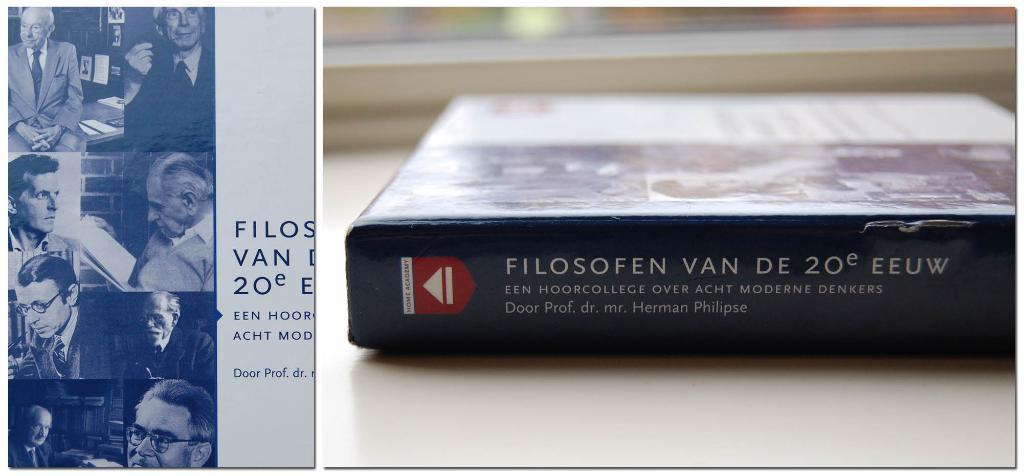<image>
Summarize the visual content of the image. A book called Filosofen Van De 20e EEUW sits on a table. 